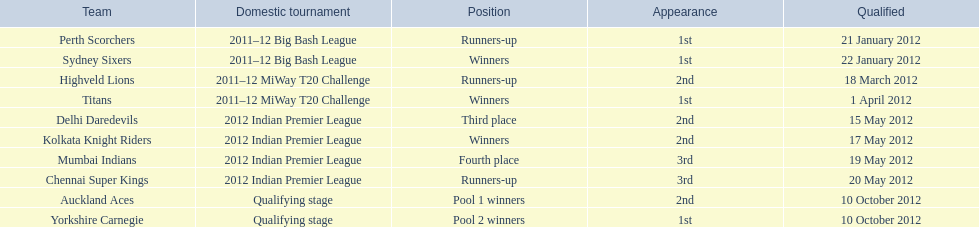Which groups were the final ones to make it through the qualification process? Auckland Aces, Yorkshire Carnegie. 